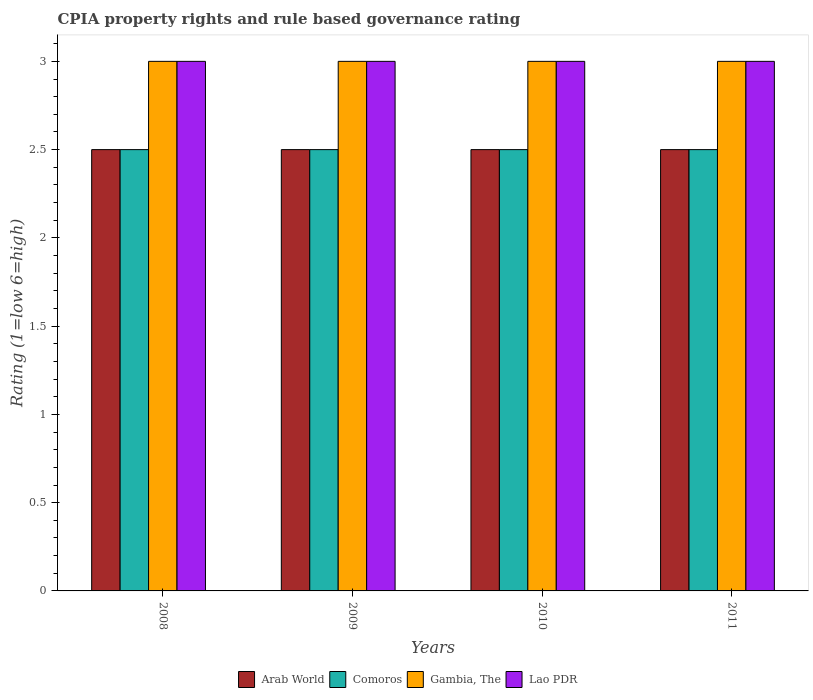How many different coloured bars are there?
Offer a terse response. 4. Are the number of bars per tick equal to the number of legend labels?
Make the answer very short. Yes. Are the number of bars on each tick of the X-axis equal?
Make the answer very short. Yes. How many bars are there on the 3rd tick from the left?
Ensure brevity in your answer.  4. What is the label of the 2nd group of bars from the left?
Provide a succinct answer. 2009. What is the CPIA rating in Comoros in 2009?
Give a very brief answer. 2.5. Across all years, what is the maximum CPIA rating in Lao PDR?
Your answer should be compact. 3. Across all years, what is the minimum CPIA rating in Comoros?
Your response must be concise. 2.5. What is the total CPIA rating in Lao PDR in the graph?
Give a very brief answer. 12. What is the difference between the CPIA rating in Comoros in 2008 and that in 2009?
Your response must be concise. 0. What is the difference between the CPIA rating in Lao PDR in 2010 and the CPIA rating in Comoros in 2009?
Ensure brevity in your answer.  0.5. What is the average CPIA rating in Gambia, The per year?
Provide a succinct answer. 3. In the year 2008, what is the difference between the CPIA rating in Gambia, The and CPIA rating in Comoros?
Your answer should be compact. 0.5. In how many years, is the CPIA rating in Comoros greater than 3?
Offer a very short reply. 0. Is the CPIA rating in Comoros in 2009 less than that in 2011?
Provide a succinct answer. No. Is the difference between the CPIA rating in Gambia, The in 2008 and 2011 greater than the difference between the CPIA rating in Comoros in 2008 and 2011?
Your response must be concise. No. What is the difference between the highest and the lowest CPIA rating in Gambia, The?
Offer a terse response. 0. What does the 4th bar from the left in 2010 represents?
Offer a terse response. Lao PDR. What does the 2nd bar from the right in 2010 represents?
Provide a succinct answer. Gambia, The. How many bars are there?
Give a very brief answer. 16. Are all the bars in the graph horizontal?
Your answer should be very brief. No. What is the difference between two consecutive major ticks on the Y-axis?
Your answer should be very brief. 0.5. Are the values on the major ticks of Y-axis written in scientific E-notation?
Offer a terse response. No. Does the graph contain grids?
Your answer should be very brief. No. How many legend labels are there?
Provide a short and direct response. 4. How are the legend labels stacked?
Your response must be concise. Horizontal. What is the title of the graph?
Your answer should be very brief. CPIA property rights and rule based governance rating. Does "Singapore" appear as one of the legend labels in the graph?
Give a very brief answer. No. What is the label or title of the X-axis?
Ensure brevity in your answer.  Years. What is the Rating (1=low 6=high) in Arab World in 2008?
Ensure brevity in your answer.  2.5. What is the Rating (1=low 6=high) of Lao PDR in 2008?
Provide a short and direct response. 3. What is the Rating (1=low 6=high) of Comoros in 2009?
Give a very brief answer. 2.5. What is the Rating (1=low 6=high) in Lao PDR in 2009?
Keep it short and to the point. 3. What is the Rating (1=low 6=high) in Arab World in 2010?
Your answer should be compact. 2.5. What is the Rating (1=low 6=high) of Comoros in 2010?
Your response must be concise. 2.5. What is the Rating (1=low 6=high) of Gambia, The in 2010?
Your response must be concise. 3. What is the Rating (1=low 6=high) of Lao PDR in 2010?
Make the answer very short. 3. What is the Rating (1=low 6=high) of Arab World in 2011?
Offer a very short reply. 2.5. What is the Rating (1=low 6=high) in Gambia, The in 2011?
Offer a very short reply. 3. What is the Rating (1=low 6=high) of Lao PDR in 2011?
Offer a very short reply. 3. Across all years, what is the maximum Rating (1=low 6=high) in Arab World?
Your answer should be compact. 2.5. Across all years, what is the maximum Rating (1=low 6=high) of Comoros?
Provide a succinct answer. 2.5. Across all years, what is the maximum Rating (1=low 6=high) of Gambia, The?
Make the answer very short. 3. Across all years, what is the minimum Rating (1=low 6=high) of Gambia, The?
Offer a very short reply. 3. Across all years, what is the minimum Rating (1=low 6=high) of Lao PDR?
Make the answer very short. 3. What is the total Rating (1=low 6=high) in Comoros in the graph?
Give a very brief answer. 10. What is the total Rating (1=low 6=high) of Gambia, The in the graph?
Offer a very short reply. 12. What is the difference between the Rating (1=low 6=high) in Arab World in 2008 and that in 2009?
Keep it short and to the point. 0. What is the difference between the Rating (1=low 6=high) of Gambia, The in 2008 and that in 2009?
Ensure brevity in your answer.  0. What is the difference between the Rating (1=low 6=high) of Lao PDR in 2008 and that in 2010?
Keep it short and to the point. 0. What is the difference between the Rating (1=low 6=high) in Arab World in 2008 and that in 2011?
Make the answer very short. 0. What is the difference between the Rating (1=low 6=high) of Gambia, The in 2008 and that in 2011?
Provide a short and direct response. 0. What is the difference between the Rating (1=low 6=high) of Arab World in 2009 and that in 2010?
Provide a succinct answer. 0. What is the difference between the Rating (1=low 6=high) in Gambia, The in 2009 and that in 2010?
Provide a short and direct response. 0. What is the difference between the Rating (1=low 6=high) in Gambia, The in 2009 and that in 2011?
Your answer should be compact. 0. What is the difference between the Rating (1=low 6=high) in Lao PDR in 2009 and that in 2011?
Keep it short and to the point. 0. What is the difference between the Rating (1=low 6=high) in Arab World in 2010 and that in 2011?
Offer a terse response. 0. What is the difference between the Rating (1=low 6=high) of Lao PDR in 2010 and that in 2011?
Make the answer very short. 0. What is the difference between the Rating (1=low 6=high) of Arab World in 2008 and the Rating (1=low 6=high) of Comoros in 2009?
Make the answer very short. 0. What is the difference between the Rating (1=low 6=high) of Comoros in 2008 and the Rating (1=low 6=high) of Lao PDR in 2009?
Your response must be concise. -0.5. What is the difference between the Rating (1=low 6=high) of Arab World in 2008 and the Rating (1=low 6=high) of Lao PDR in 2010?
Offer a very short reply. -0.5. What is the difference between the Rating (1=low 6=high) of Comoros in 2008 and the Rating (1=low 6=high) of Lao PDR in 2010?
Keep it short and to the point. -0.5. What is the difference between the Rating (1=low 6=high) of Gambia, The in 2008 and the Rating (1=low 6=high) of Lao PDR in 2010?
Offer a very short reply. 0. What is the difference between the Rating (1=low 6=high) in Arab World in 2008 and the Rating (1=low 6=high) in Comoros in 2011?
Offer a very short reply. 0. What is the difference between the Rating (1=low 6=high) in Comoros in 2008 and the Rating (1=low 6=high) in Gambia, The in 2011?
Your response must be concise. -0.5. What is the difference between the Rating (1=low 6=high) of Comoros in 2008 and the Rating (1=low 6=high) of Lao PDR in 2011?
Your response must be concise. -0.5. What is the difference between the Rating (1=low 6=high) in Arab World in 2009 and the Rating (1=low 6=high) in Gambia, The in 2010?
Your response must be concise. -0.5. What is the difference between the Rating (1=low 6=high) of Arab World in 2009 and the Rating (1=low 6=high) of Lao PDR in 2010?
Offer a very short reply. -0.5. What is the difference between the Rating (1=low 6=high) of Gambia, The in 2009 and the Rating (1=low 6=high) of Lao PDR in 2010?
Your answer should be very brief. 0. What is the difference between the Rating (1=low 6=high) in Arab World in 2009 and the Rating (1=low 6=high) in Comoros in 2011?
Your answer should be very brief. 0. What is the difference between the Rating (1=low 6=high) in Arab World in 2009 and the Rating (1=low 6=high) in Gambia, The in 2011?
Keep it short and to the point. -0.5. What is the difference between the Rating (1=low 6=high) of Arab World in 2009 and the Rating (1=low 6=high) of Lao PDR in 2011?
Your answer should be compact. -0.5. What is the difference between the Rating (1=low 6=high) of Gambia, The in 2009 and the Rating (1=low 6=high) of Lao PDR in 2011?
Make the answer very short. 0. What is the difference between the Rating (1=low 6=high) in Arab World in 2010 and the Rating (1=low 6=high) in Lao PDR in 2011?
Make the answer very short. -0.5. What is the difference between the Rating (1=low 6=high) in Comoros in 2010 and the Rating (1=low 6=high) in Gambia, The in 2011?
Provide a short and direct response. -0.5. What is the difference between the Rating (1=low 6=high) of Comoros in 2010 and the Rating (1=low 6=high) of Lao PDR in 2011?
Offer a terse response. -0.5. What is the difference between the Rating (1=low 6=high) of Gambia, The in 2010 and the Rating (1=low 6=high) of Lao PDR in 2011?
Provide a succinct answer. 0. What is the average Rating (1=low 6=high) in Arab World per year?
Your response must be concise. 2.5. What is the average Rating (1=low 6=high) in Gambia, The per year?
Give a very brief answer. 3. In the year 2008, what is the difference between the Rating (1=low 6=high) of Arab World and Rating (1=low 6=high) of Comoros?
Ensure brevity in your answer.  0. In the year 2008, what is the difference between the Rating (1=low 6=high) of Arab World and Rating (1=low 6=high) of Gambia, The?
Offer a very short reply. -0.5. In the year 2008, what is the difference between the Rating (1=low 6=high) in Comoros and Rating (1=low 6=high) in Gambia, The?
Your answer should be compact. -0.5. In the year 2008, what is the difference between the Rating (1=low 6=high) of Comoros and Rating (1=low 6=high) of Lao PDR?
Provide a short and direct response. -0.5. In the year 2009, what is the difference between the Rating (1=low 6=high) of Arab World and Rating (1=low 6=high) of Comoros?
Offer a terse response. 0. In the year 2009, what is the difference between the Rating (1=low 6=high) in Comoros and Rating (1=low 6=high) in Gambia, The?
Make the answer very short. -0.5. In the year 2010, what is the difference between the Rating (1=low 6=high) of Arab World and Rating (1=low 6=high) of Comoros?
Provide a succinct answer. 0. In the year 2010, what is the difference between the Rating (1=low 6=high) of Arab World and Rating (1=low 6=high) of Lao PDR?
Ensure brevity in your answer.  -0.5. In the year 2010, what is the difference between the Rating (1=low 6=high) of Comoros and Rating (1=low 6=high) of Gambia, The?
Your answer should be compact. -0.5. In the year 2011, what is the difference between the Rating (1=low 6=high) of Comoros and Rating (1=low 6=high) of Gambia, The?
Offer a terse response. -0.5. In the year 2011, what is the difference between the Rating (1=low 6=high) in Comoros and Rating (1=low 6=high) in Lao PDR?
Give a very brief answer. -0.5. What is the ratio of the Rating (1=low 6=high) of Comoros in 2008 to that in 2009?
Offer a terse response. 1. What is the ratio of the Rating (1=low 6=high) in Arab World in 2008 to that in 2010?
Offer a very short reply. 1. What is the ratio of the Rating (1=low 6=high) in Comoros in 2008 to that in 2010?
Provide a succinct answer. 1. What is the ratio of the Rating (1=low 6=high) of Gambia, The in 2008 to that in 2010?
Keep it short and to the point. 1. What is the ratio of the Rating (1=low 6=high) in Lao PDR in 2008 to that in 2011?
Provide a succinct answer. 1. What is the ratio of the Rating (1=low 6=high) in Arab World in 2009 to that in 2010?
Make the answer very short. 1. What is the ratio of the Rating (1=low 6=high) of Comoros in 2010 to that in 2011?
Ensure brevity in your answer.  1. What is the ratio of the Rating (1=low 6=high) of Lao PDR in 2010 to that in 2011?
Make the answer very short. 1. What is the difference between the highest and the second highest Rating (1=low 6=high) in Comoros?
Give a very brief answer. 0. What is the difference between the highest and the second highest Rating (1=low 6=high) in Lao PDR?
Your answer should be very brief. 0. What is the difference between the highest and the lowest Rating (1=low 6=high) of Arab World?
Your answer should be very brief. 0. What is the difference between the highest and the lowest Rating (1=low 6=high) in Gambia, The?
Provide a succinct answer. 0. What is the difference between the highest and the lowest Rating (1=low 6=high) of Lao PDR?
Offer a terse response. 0. 